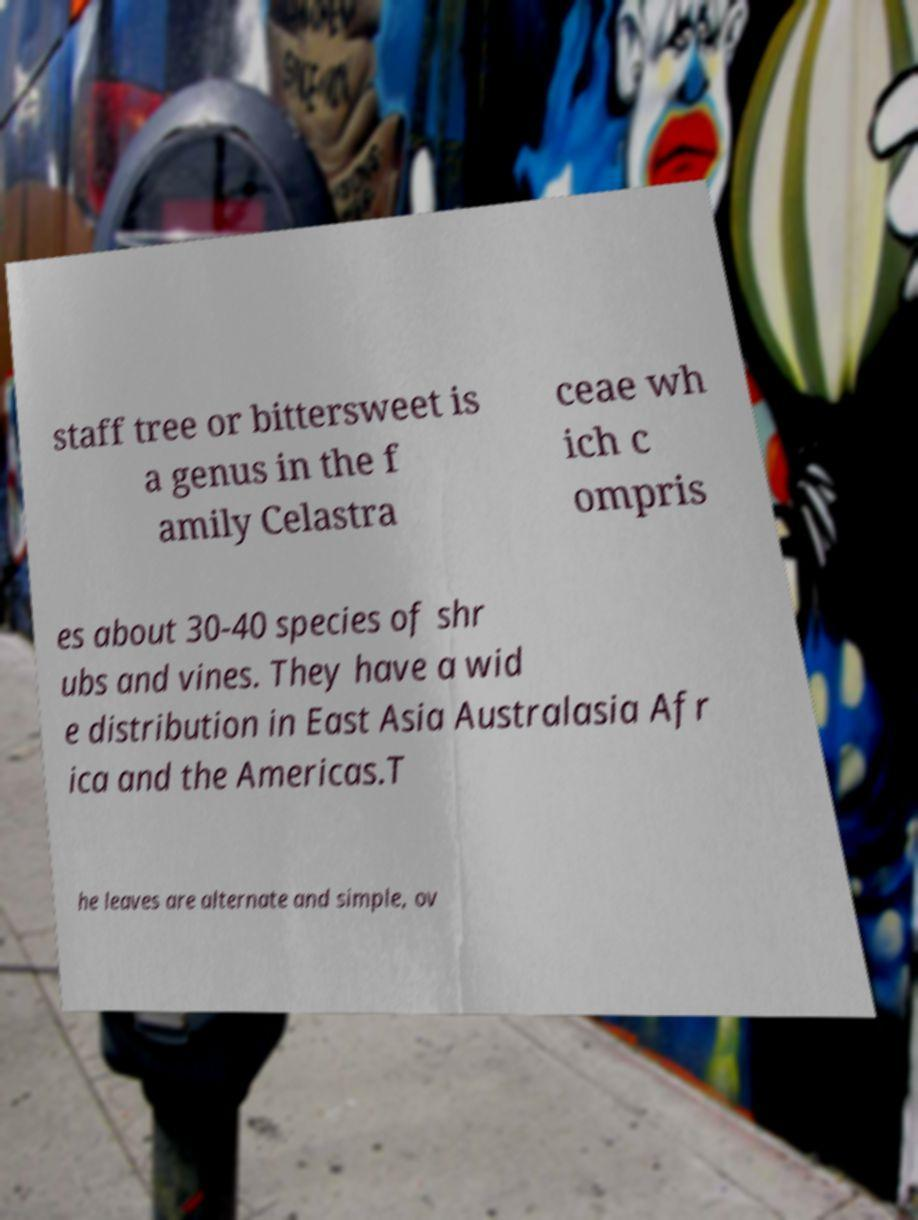Please identify and transcribe the text found in this image. staff tree or bittersweet is a genus in the f amily Celastra ceae wh ich c ompris es about 30-40 species of shr ubs and vines. They have a wid e distribution in East Asia Australasia Afr ica and the Americas.T he leaves are alternate and simple, ov 